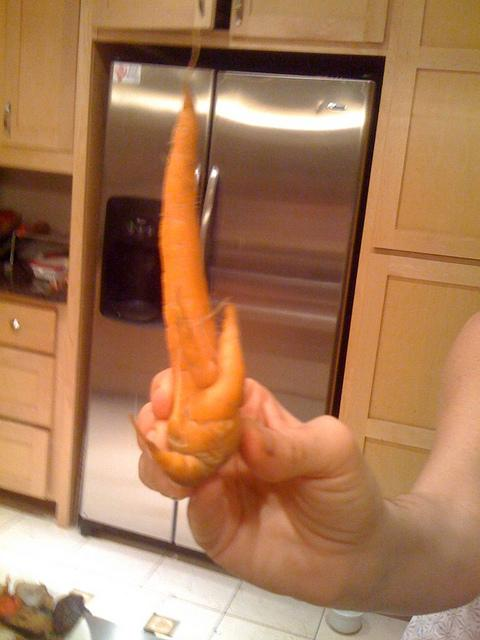What food category is this object in? Please explain your reasoning. vegetable. It is a carrot. 